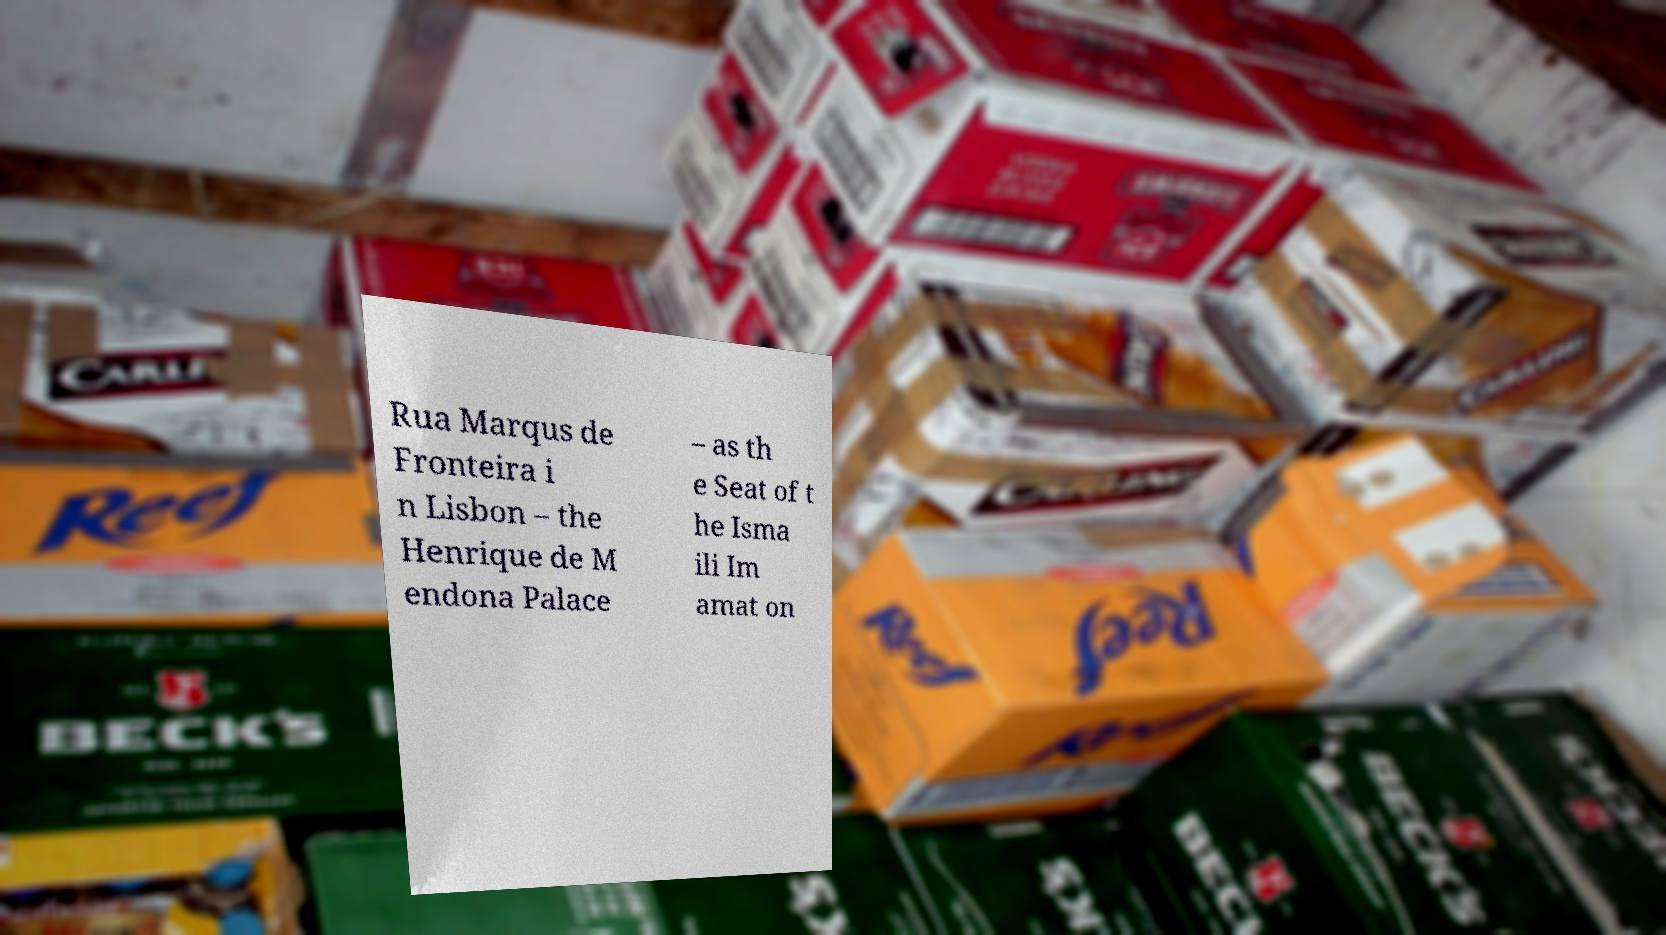For documentation purposes, I need the text within this image transcribed. Could you provide that? Rua Marqus de Fronteira i n Lisbon – the Henrique de M endona Palace – as th e Seat of t he Isma ili Im amat on 